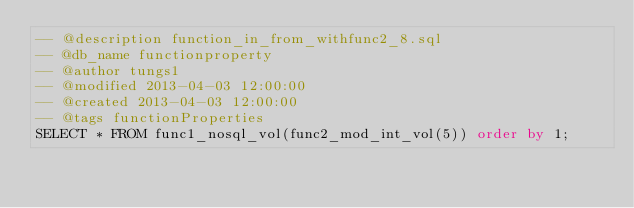<code> <loc_0><loc_0><loc_500><loc_500><_SQL_>-- @description function_in_from_withfunc2_8.sql
-- @db_name functionproperty
-- @author tungs1
-- @modified 2013-04-03 12:00:00
-- @created 2013-04-03 12:00:00
-- @tags functionProperties 
SELECT * FROM func1_nosql_vol(func2_mod_int_vol(5)) order by 1; 
</code> 